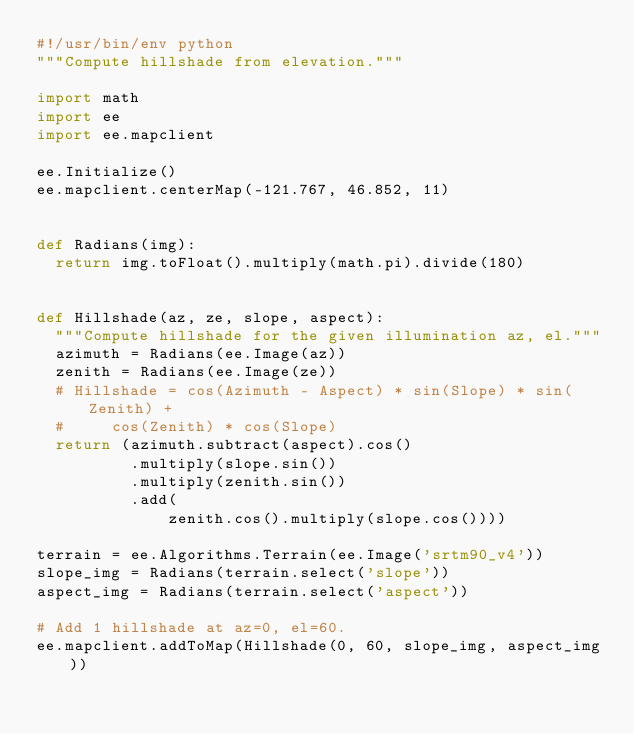<code> <loc_0><loc_0><loc_500><loc_500><_Python_>#!/usr/bin/env python
"""Compute hillshade from elevation."""

import math
import ee
import ee.mapclient

ee.Initialize()
ee.mapclient.centerMap(-121.767, 46.852, 11)


def Radians(img):
  return img.toFloat().multiply(math.pi).divide(180)


def Hillshade(az, ze, slope, aspect):
  """Compute hillshade for the given illumination az, el."""
  azimuth = Radians(ee.Image(az))
  zenith = Radians(ee.Image(ze))
  # Hillshade = cos(Azimuth - Aspect) * sin(Slope) * sin(Zenith) +
  #     cos(Zenith) * cos(Slope)
  return (azimuth.subtract(aspect).cos()
          .multiply(slope.sin())
          .multiply(zenith.sin())
          .add(
              zenith.cos().multiply(slope.cos())))

terrain = ee.Algorithms.Terrain(ee.Image('srtm90_v4'))
slope_img = Radians(terrain.select('slope'))
aspect_img = Radians(terrain.select('aspect'))

# Add 1 hillshade at az=0, el=60.
ee.mapclient.addToMap(Hillshade(0, 60, slope_img, aspect_img))
</code> 